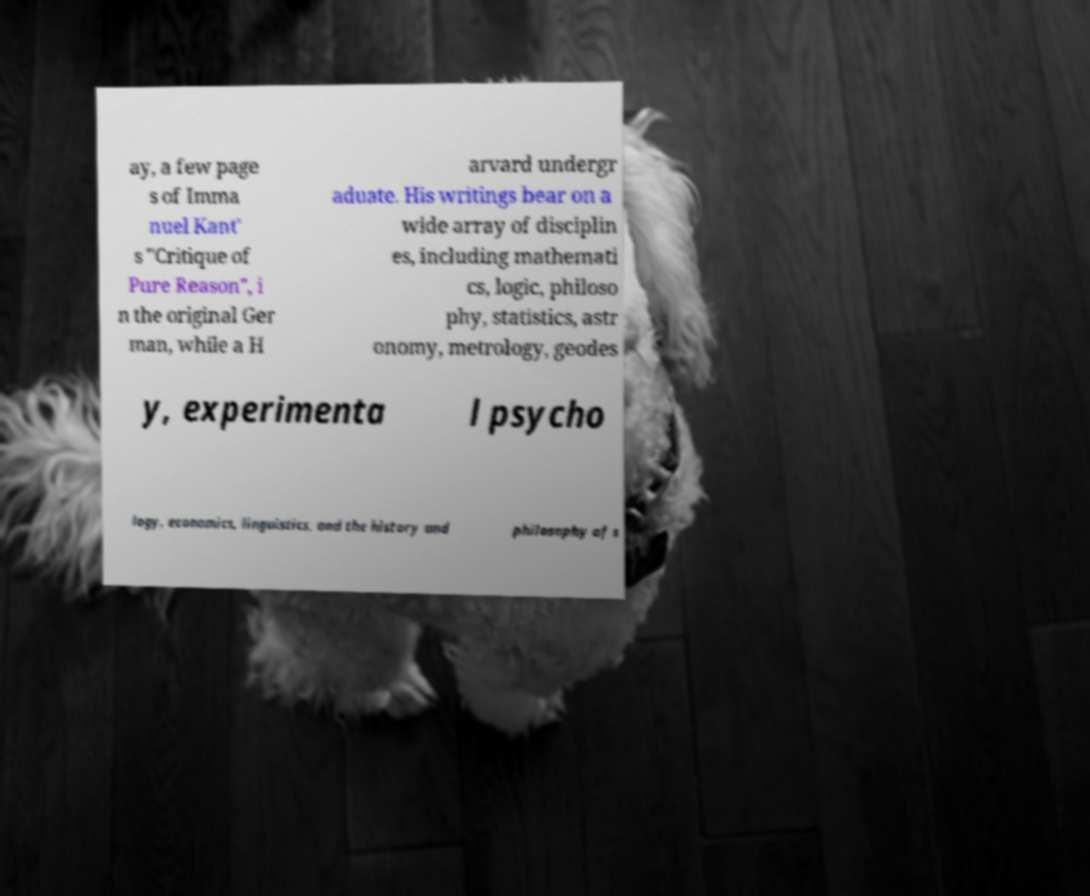Could you assist in decoding the text presented in this image and type it out clearly? ay, a few page s of Imma nuel Kant' s "Critique of Pure Reason", i n the original Ger man, while a H arvard undergr aduate. His writings bear on a wide array of disciplin es, including mathemati cs, logic, philoso phy, statistics, astr onomy, metrology, geodes y, experimenta l psycho logy, economics, linguistics, and the history and philosophy of s 